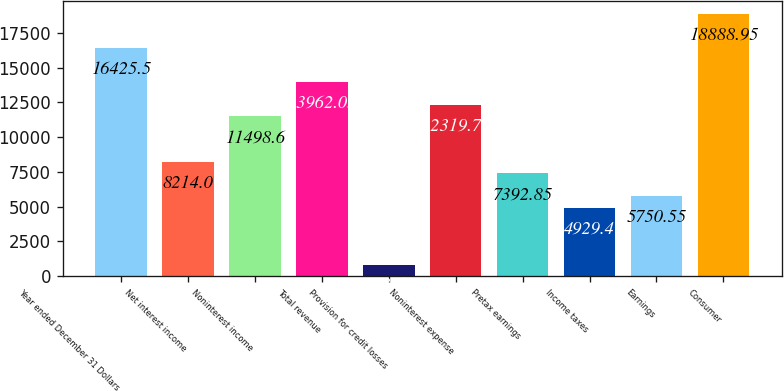<chart> <loc_0><loc_0><loc_500><loc_500><bar_chart><fcel>Year ended December 31 Dollars<fcel>Net interest income<fcel>Noninterest income<fcel>Total revenue<fcel>Provision for credit losses<fcel>Noninterest expense<fcel>Pretax earnings<fcel>Income taxes<fcel>Earnings<fcel>Consumer<nl><fcel>16425.5<fcel>8214<fcel>11498.6<fcel>13962<fcel>823.65<fcel>12319.8<fcel>7392.85<fcel>4929.4<fcel>5750.55<fcel>18889<nl></chart> 